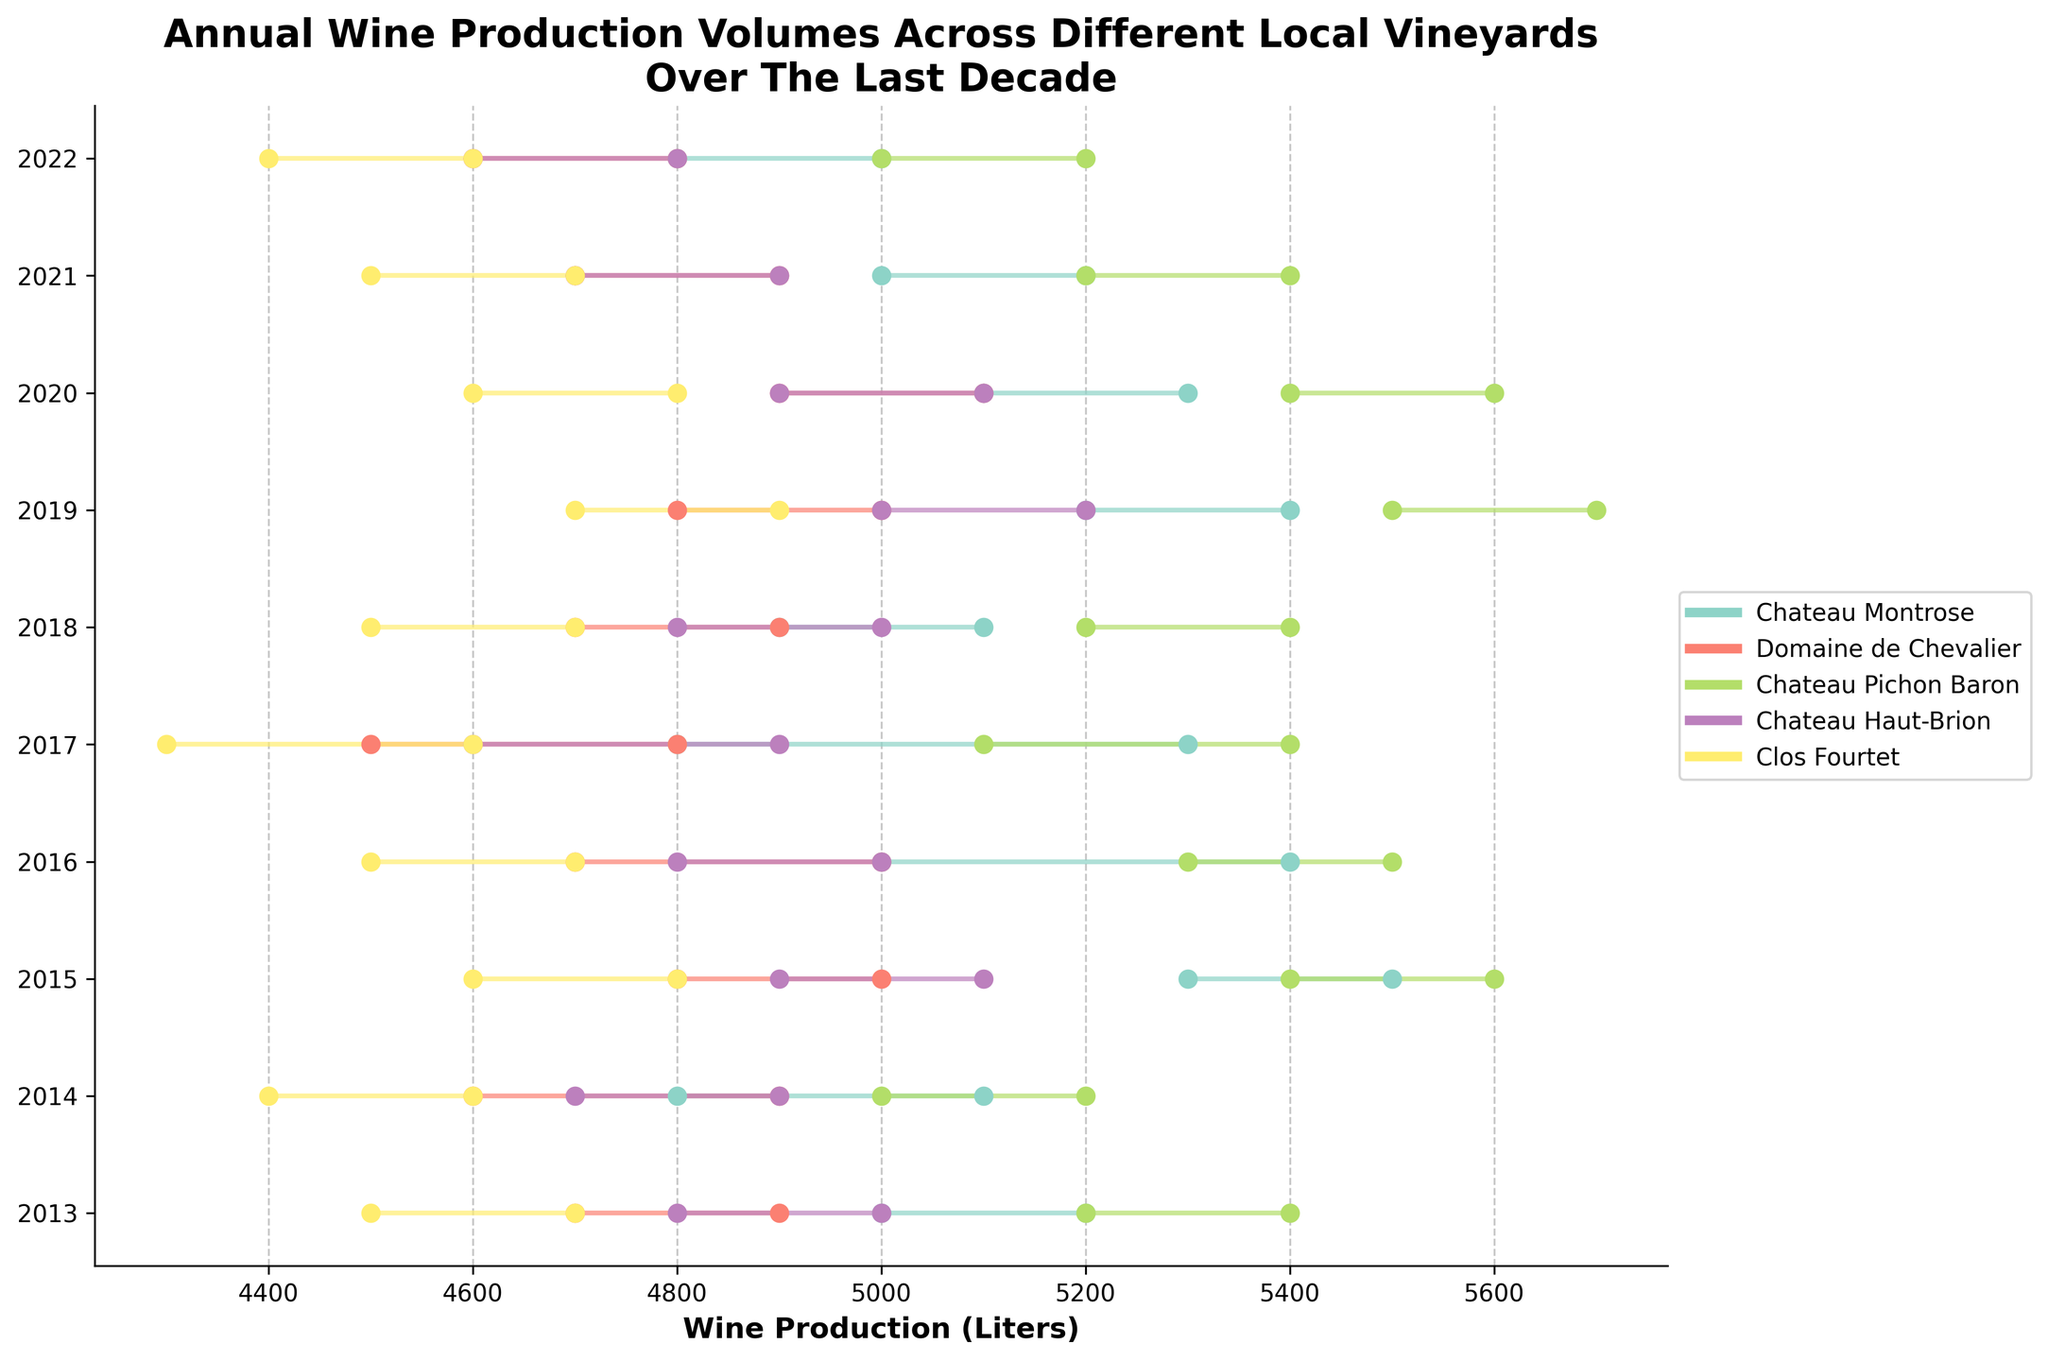What is the overall title of the plot? The title of the plot is always displayed prominently at the top. It provides a summary of what the plot represents.
Answer: Annual Wine Production Volumes Across Different Local Vineyards Over The Last Decade Which vineyard had the highest maximum wine production in any given year? To find the highest maximum wine production, identify the vineyard with the highest point on the right end of any horizontal line in the plot. Compare all the vineyards.
Answer: Chateau Pichon Baron During which year did 'Chateau Montrose' have its lowest minimum production? Locate the range of production values for 'Chateau Montrose' across the years. Identify the year with the smallest value on the left end of its range.
Answer: 2017, 2022 Compare the wine production ranges for 'Clos Fourtet' between 2013 and 2022. How did it change? Examine the starting and ending points of the horizontal lines for 'Clos Fourtet' in 2013 and 2022. Compare the minimum and maximum production values in both years.
Answer: The range decreased both in minimum and maximum values from 4500-4700 in 2013 to 4400-4600 in 2022 Which vineyard had the most stable production range over the decade? Stability can be inferred from smaller fluctuations in the lengths of the horizontal lines representing production ranges. Identify the vineyard with the most consistent range lengths over the years.
Answer: Clos Fourtet What was the trend in wine production for 'Chateau Haut-Brion' from 2013 to 2022? Review the horizontal lines for 'Chateau Haut-Brion' over the years. Analyze the change in the position of dots from left to right (min to max) to identify if there is an upward, downward, or neutral trend.
Answer: Slight downward trend Which vineyard had the widest production range in any single year? Search for the longest horizontal line in the plot, indicating the widest range between min and max production for any vineyard in a single year. Identify the corresponding vineyard.
Answer: Chateau Pichon Baron in 2015 How does the annual production of 'Domaine de Chevalier' in 2015 compare to 2019? Locate the production ranges for 'Domaine de Chevalier' in 2015 and 2019. Compare the positions and lengths of the lines to understand the differences in min and max production values.
Answer: Range: 4800-5000 in 2015, 4800-5000 in 2019; no significant change Among all vineyards, which year had the lowest minimum production? Identify the lowest point on the left end of any vineyard's production range across all years. Determine the corresponding year.
Answer: Clos Fourtet in 2017 